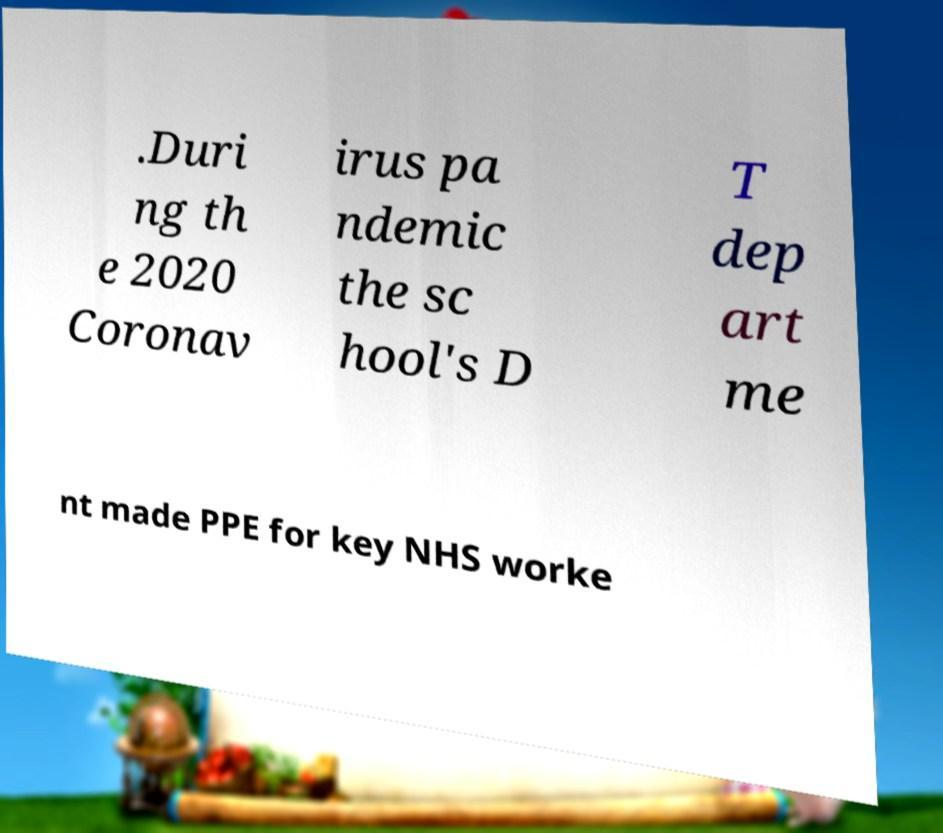Please identify and transcribe the text found in this image. .Duri ng th e 2020 Coronav irus pa ndemic the sc hool's D T dep art me nt made PPE for key NHS worke 